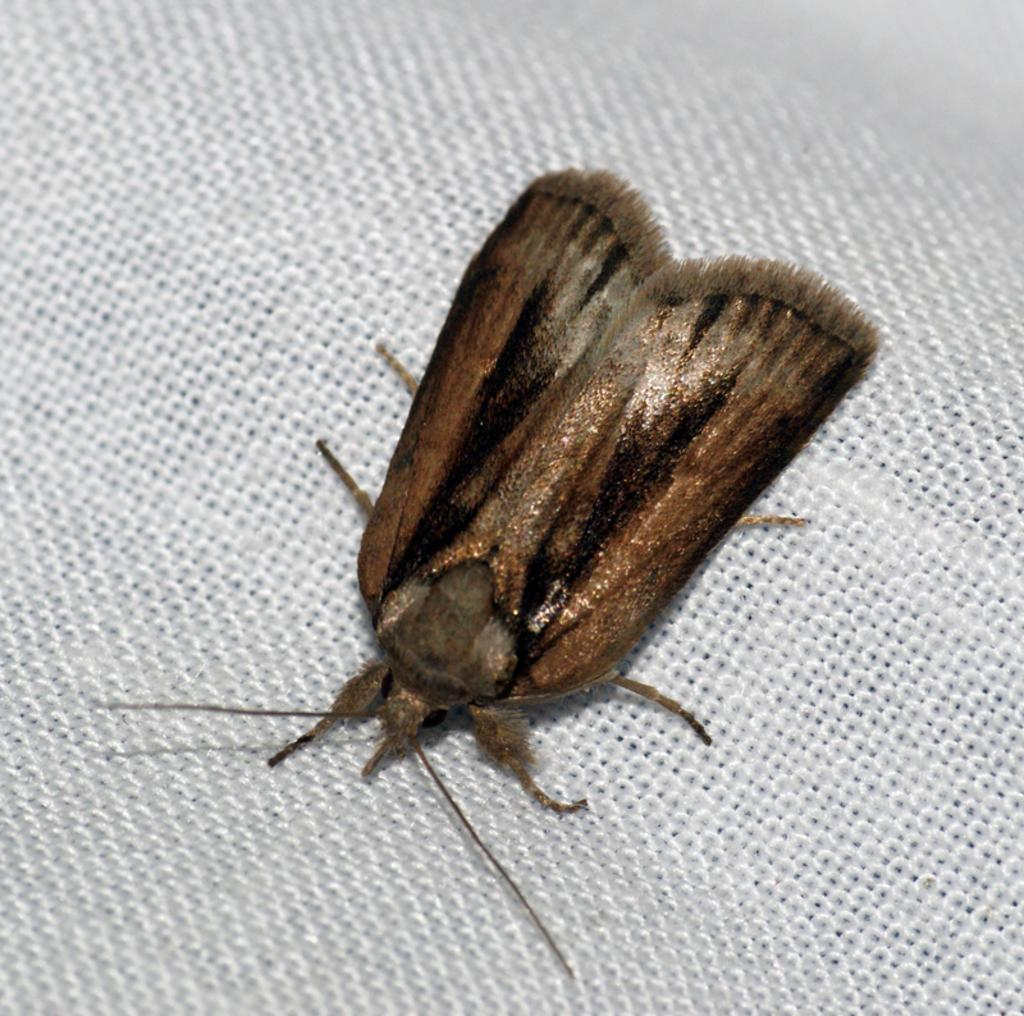What is the main subject of the image? There is an insect in the center of the image. What type of wren can be seen in the image? There is no wren present in the image; it features an insect. How is the insect distributed throughout the image? The insect is located in the center of the image, so it is not distributed throughout the image. 